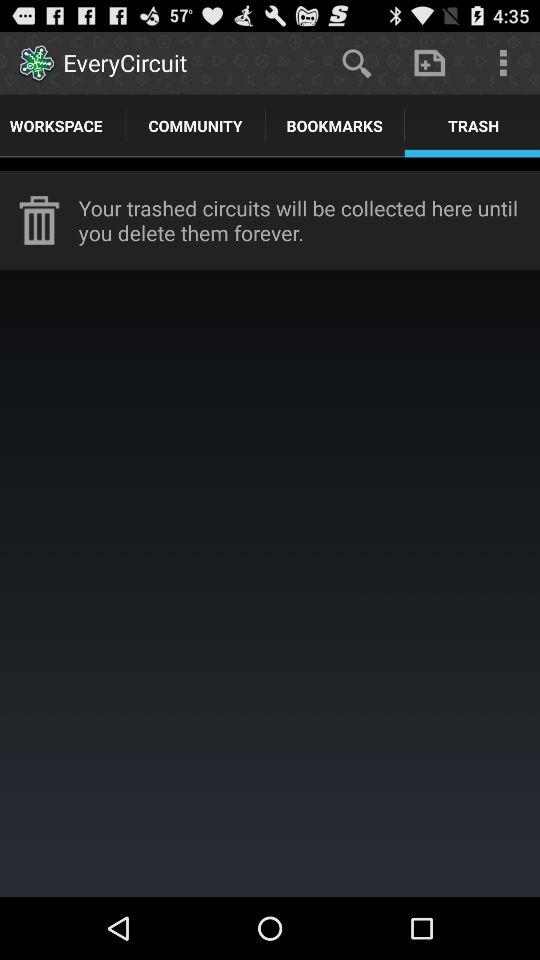What is the application name? The application name is "EveryCircuit". 